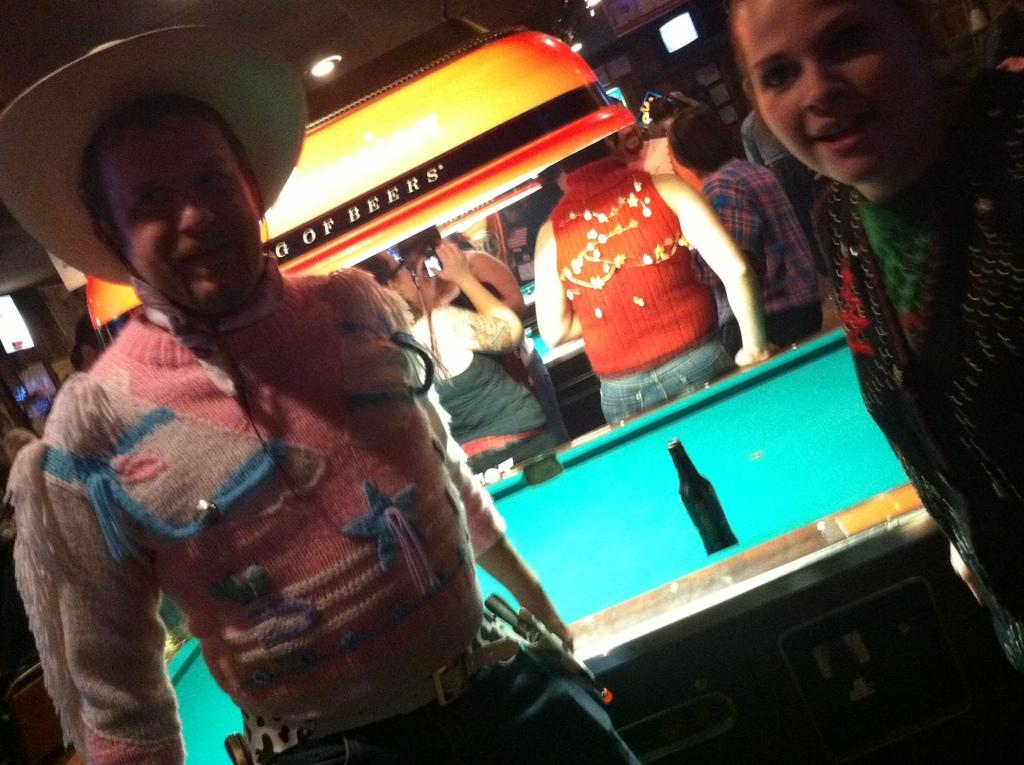What can be seen in the image that provides illumination? There is a light in the image. Who or what is present in the image? There are people in the image. What type of game or activity is being played in the image? There is a billiards board in the image, suggesting that billiards is being played. What is placed on the billiards board? There is a bottle on the billiards board. What is the opinion of the cannon in the image? There is no cannon present in the image, so it cannot have an opinion. What type of system is being used to play the game in the image? The provided facts do not mention a specific system being used to play the game, so we cannot determine the type of system from the image. 